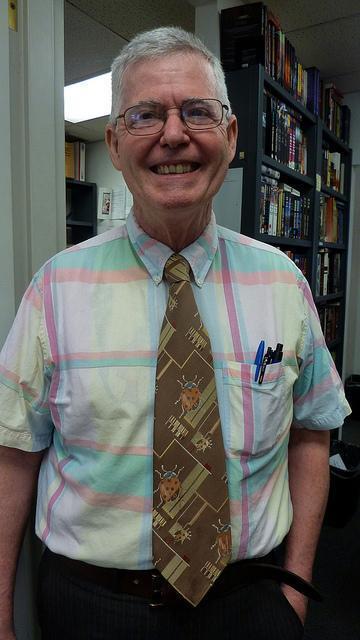How many ties is this man wearing?
Give a very brief answer. 1. How many pockets does the man's shirt have?
Give a very brief answer. 1. How many kites do you see?
Give a very brief answer. 0. 